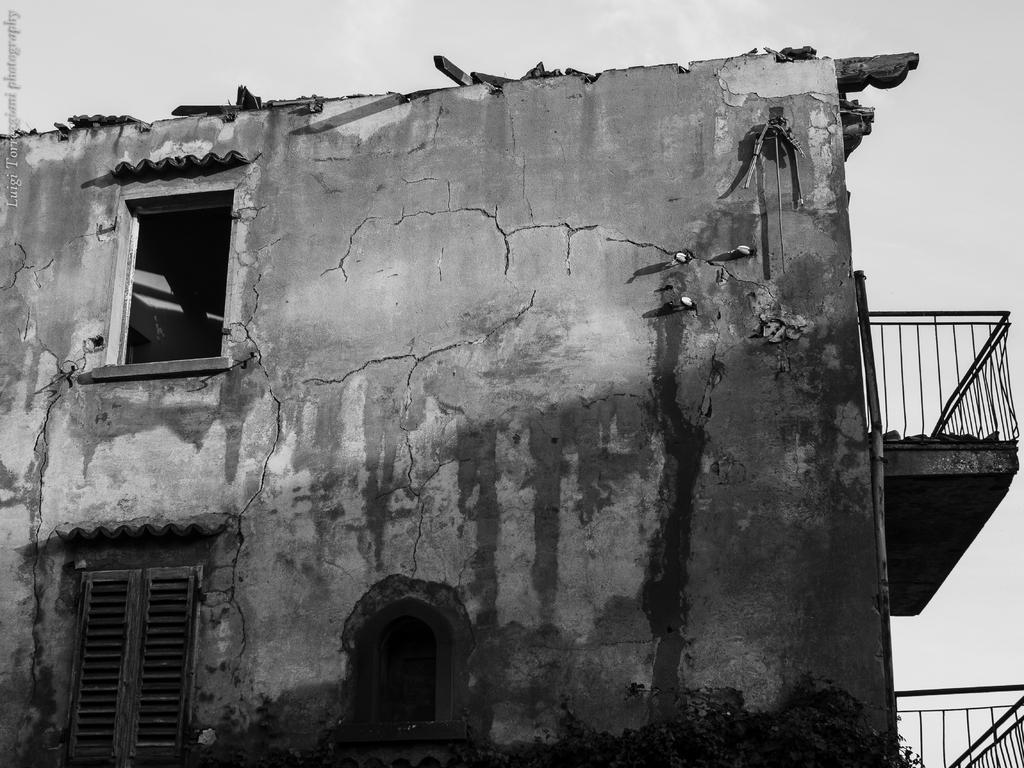In one or two sentences, can you explain what this image depicts? It looks like a black and white picture. We can see a building with windows and balconies. In front of the building there is a tree. Behind the building there is the sky. On the image there is a watermark. 